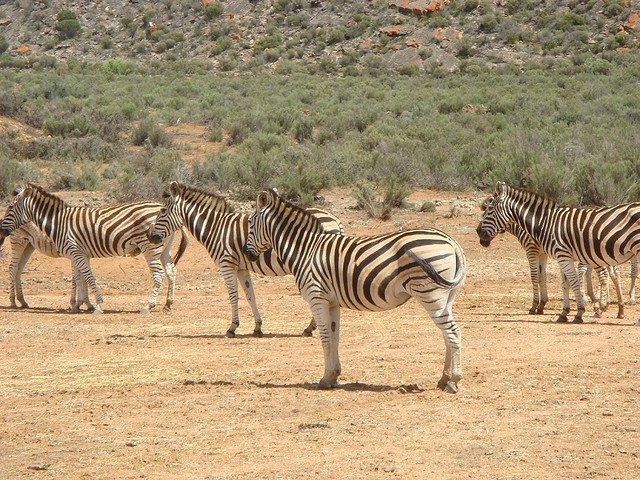Describe the objects in this image and their specific colors. I can see zebra in black, tan, and gray tones, zebra in black, maroon, tan, and gray tones, zebra in black, tan, gray, and maroon tones, zebra in black, tan, maroon, and gray tones, and zebra in black, gray, tan, and brown tones in this image. 